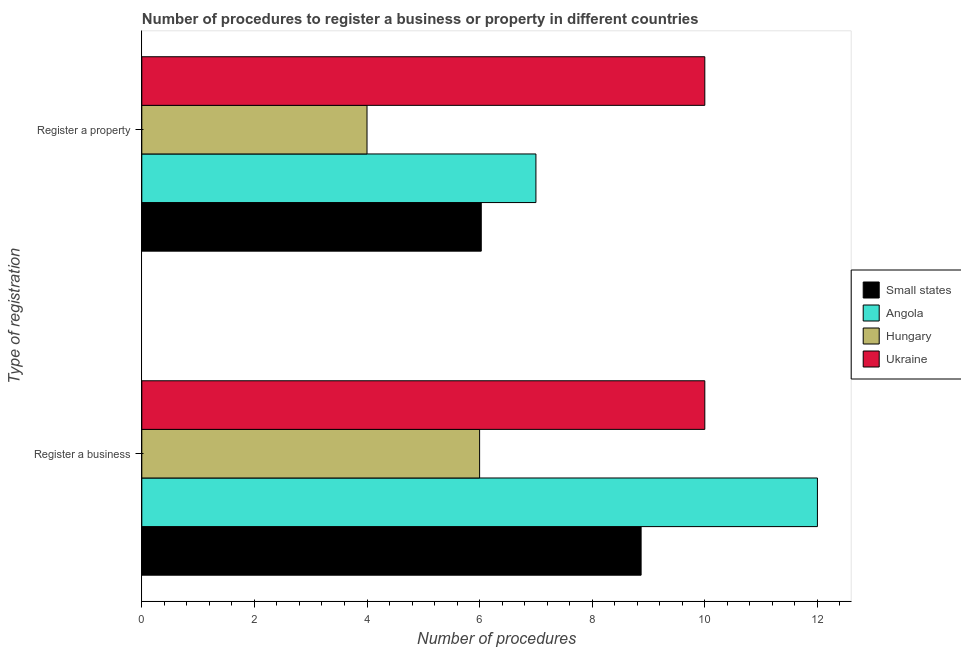How many different coloured bars are there?
Keep it short and to the point. 4. Are the number of bars per tick equal to the number of legend labels?
Offer a terse response. Yes. Are the number of bars on each tick of the Y-axis equal?
Ensure brevity in your answer.  Yes. How many bars are there on the 1st tick from the bottom?
Provide a succinct answer. 4. What is the label of the 1st group of bars from the top?
Provide a short and direct response. Register a property. Across all countries, what is the maximum number of procedures to register a property?
Ensure brevity in your answer.  10. Across all countries, what is the minimum number of procedures to register a business?
Ensure brevity in your answer.  6. In which country was the number of procedures to register a property maximum?
Your response must be concise. Ukraine. In which country was the number of procedures to register a property minimum?
Your response must be concise. Hungary. What is the total number of procedures to register a business in the graph?
Your answer should be compact. 36.87. What is the difference between the number of procedures to register a property in Small states and that in Hungary?
Provide a short and direct response. 2.03. What is the difference between the number of procedures to register a business in Angola and the number of procedures to register a property in Hungary?
Provide a succinct answer. 8. What is the average number of procedures to register a property per country?
Offer a terse response. 6.76. In how many countries, is the number of procedures to register a property greater than 2.4 ?
Offer a very short reply. 4. What is the ratio of the number of procedures to register a property in Small states to that in Hungary?
Give a very brief answer. 1.51. Is the number of procedures to register a business in Angola less than that in Hungary?
Your answer should be compact. No. In how many countries, is the number of procedures to register a property greater than the average number of procedures to register a property taken over all countries?
Provide a succinct answer. 2. What does the 3rd bar from the top in Register a property represents?
Give a very brief answer. Angola. What does the 1st bar from the bottom in Register a property represents?
Your answer should be very brief. Small states. How many bars are there?
Your response must be concise. 8. Are all the bars in the graph horizontal?
Provide a short and direct response. Yes. How many countries are there in the graph?
Your answer should be compact. 4. Are the values on the major ticks of X-axis written in scientific E-notation?
Your answer should be very brief. No. Where does the legend appear in the graph?
Make the answer very short. Center right. How many legend labels are there?
Your answer should be compact. 4. What is the title of the graph?
Your response must be concise. Number of procedures to register a business or property in different countries. Does "French Polynesia" appear as one of the legend labels in the graph?
Give a very brief answer. No. What is the label or title of the X-axis?
Ensure brevity in your answer.  Number of procedures. What is the label or title of the Y-axis?
Offer a terse response. Type of registration. What is the Number of procedures in Small states in Register a business?
Your answer should be compact. 8.87. What is the Number of procedures of Ukraine in Register a business?
Make the answer very short. 10. What is the Number of procedures in Small states in Register a property?
Give a very brief answer. 6.03. Across all Type of registration, what is the maximum Number of procedures in Small states?
Your answer should be compact. 8.87. Across all Type of registration, what is the maximum Number of procedures in Angola?
Offer a very short reply. 12. Across all Type of registration, what is the maximum Number of procedures of Ukraine?
Provide a succinct answer. 10. Across all Type of registration, what is the minimum Number of procedures in Small states?
Offer a terse response. 6.03. Across all Type of registration, what is the minimum Number of procedures of Angola?
Your answer should be compact. 7. Across all Type of registration, what is the minimum Number of procedures of Ukraine?
Offer a very short reply. 10. What is the total Number of procedures of Small states in the graph?
Make the answer very short. 14.9. What is the total Number of procedures of Angola in the graph?
Provide a short and direct response. 19. What is the total Number of procedures in Ukraine in the graph?
Offer a terse response. 20. What is the difference between the Number of procedures of Small states in Register a business and that in Register a property?
Provide a short and direct response. 2.84. What is the difference between the Number of procedures in Angola in Register a business and that in Register a property?
Keep it short and to the point. 5. What is the difference between the Number of procedures of Small states in Register a business and the Number of procedures of Angola in Register a property?
Make the answer very short. 1.87. What is the difference between the Number of procedures in Small states in Register a business and the Number of procedures in Hungary in Register a property?
Your answer should be very brief. 4.87. What is the difference between the Number of procedures of Small states in Register a business and the Number of procedures of Ukraine in Register a property?
Your response must be concise. -1.13. What is the difference between the Number of procedures of Angola in Register a business and the Number of procedures of Ukraine in Register a property?
Keep it short and to the point. 2. What is the difference between the Number of procedures in Hungary in Register a business and the Number of procedures in Ukraine in Register a property?
Keep it short and to the point. -4. What is the average Number of procedures in Small states per Type of registration?
Offer a terse response. 7.45. What is the average Number of procedures in Angola per Type of registration?
Offer a terse response. 9.5. What is the average Number of procedures of Ukraine per Type of registration?
Your response must be concise. 10. What is the difference between the Number of procedures in Small states and Number of procedures in Angola in Register a business?
Ensure brevity in your answer.  -3.13. What is the difference between the Number of procedures in Small states and Number of procedures in Hungary in Register a business?
Ensure brevity in your answer.  2.87. What is the difference between the Number of procedures in Small states and Number of procedures in Ukraine in Register a business?
Offer a terse response. -1.13. What is the difference between the Number of procedures of Angola and Number of procedures of Hungary in Register a business?
Offer a terse response. 6. What is the difference between the Number of procedures in Hungary and Number of procedures in Ukraine in Register a business?
Offer a terse response. -4. What is the difference between the Number of procedures in Small states and Number of procedures in Angola in Register a property?
Your answer should be very brief. -0.97. What is the difference between the Number of procedures of Small states and Number of procedures of Hungary in Register a property?
Offer a terse response. 2.03. What is the difference between the Number of procedures of Small states and Number of procedures of Ukraine in Register a property?
Offer a very short reply. -3.97. What is the ratio of the Number of procedures in Small states in Register a business to that in Register a property?
Your response must be concise. 1.47. What is the ratio of the Number of procedures in Angola in Register a business to that in Register a property?
Make the answer very short. 1.71. What is the ratio of the Number of procedures of Hungary in Register a business to that in Register a property?
Ensure brevity in your answer.  1.5. What is the ratio of the Number of procedures in Ukraine in Register a business to that in Register a property?
Offer a terse response. 1. What is the difference between the highest and the second highest Number of procedures in Small states?
Your response must be concise. 2.84. What is the difference between the highest and the second highest Number of procedures of Angola?
Your answer should be compact. 5. What is the difference between the highest and the lowest Number of procedures of Small states?
Offer a very short reply. 2.84. What is the difference between the highest and the lowest Number of procedures of Angola?
Your answer should be compact. 5. What is the difference between the highest and the lowest Number of procedures in Hungary?
Give a very brief answer. 2. 